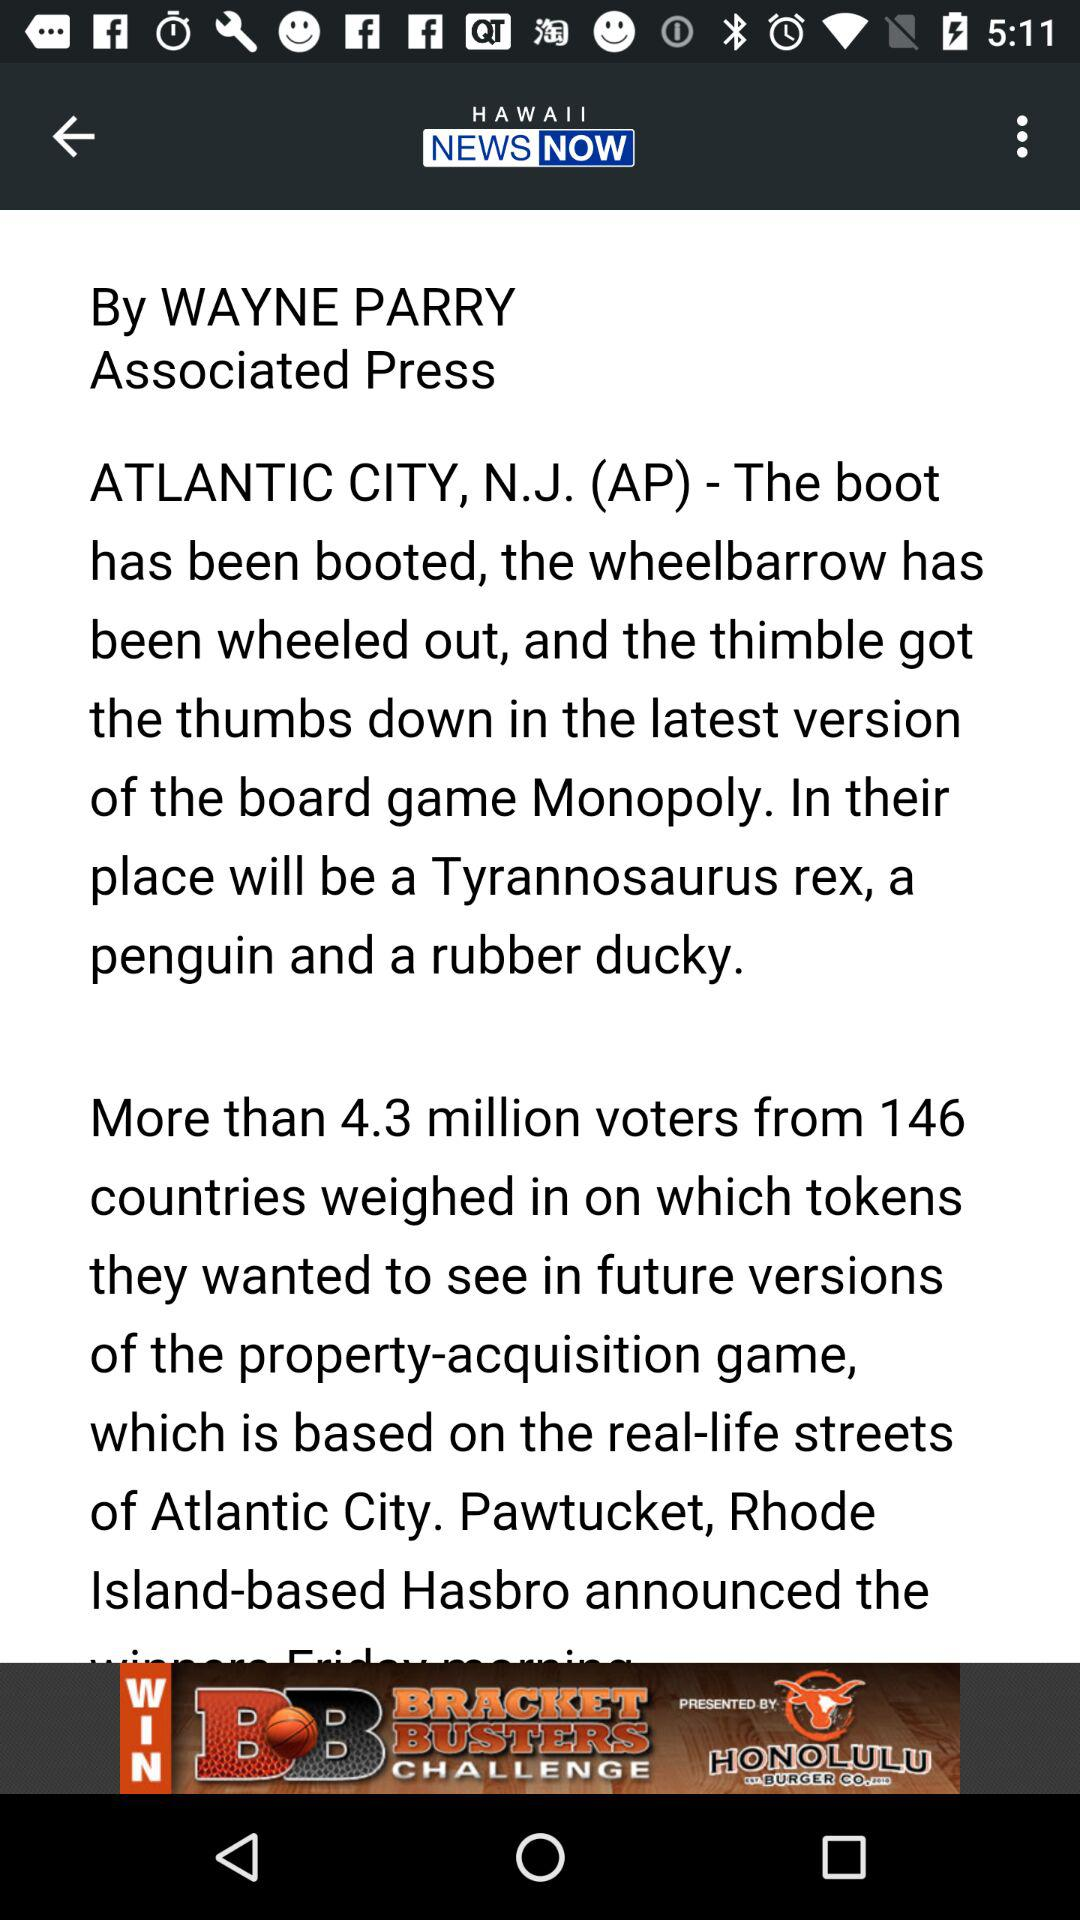What is the author name? The author name is Wayne Parry. 